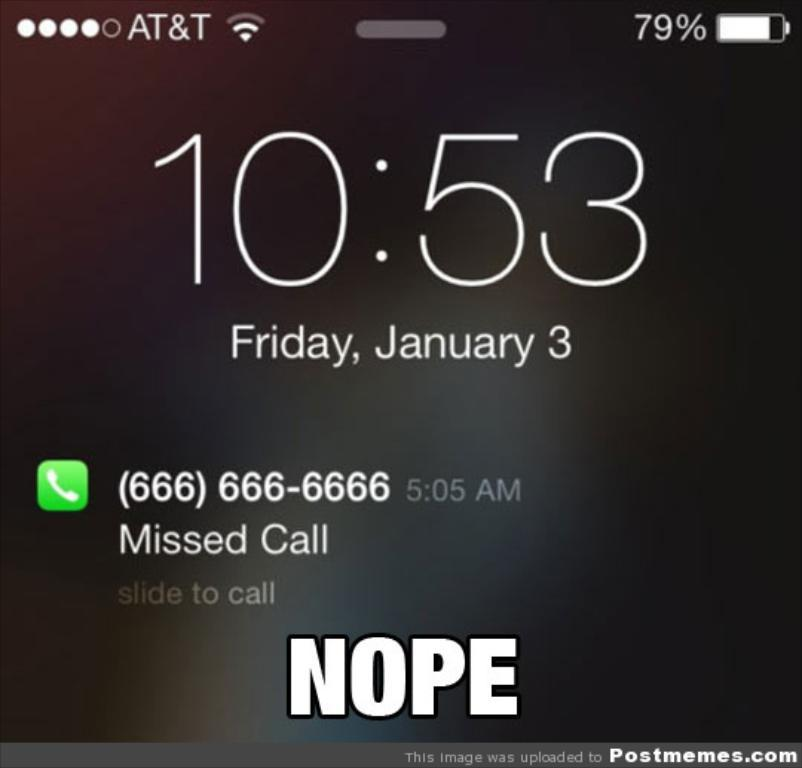What is the main subject of the image? The main subject of the image is the screen of a mobile phone. Can you describe the screen of the mobile phone? Unfortunately, the specific content on the screen cannot be determined from the image alone. What is the context of the image? The context of the image is the screen of a mobile phone. What type of grain is stored in the cellar in the image? There is no cellar or grain present in the image; it only contains the screen of a mobile phone. 